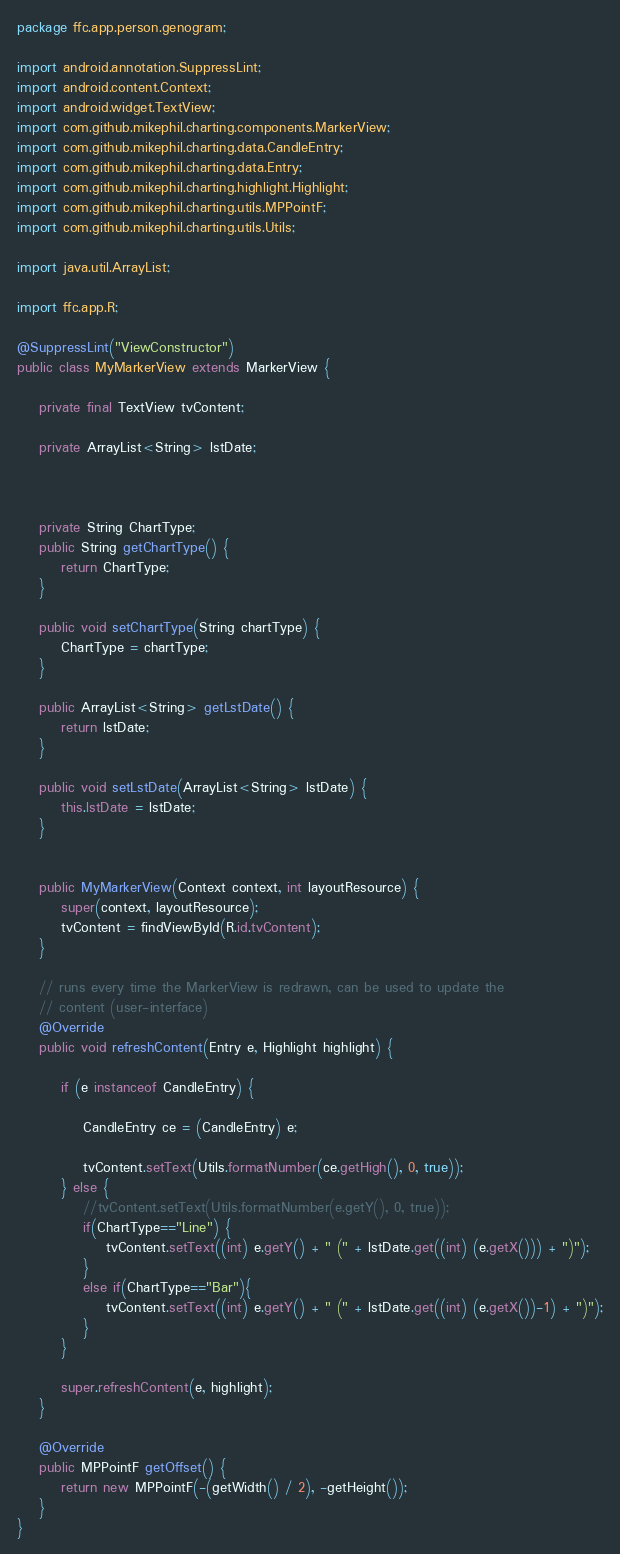<code> <loc_0><loc_0><loc_500><loc_500><_Java_>package ffc.app.person.genogram;

import android.annotation.SuppressLint;
import android.content.Context;
import android.widget.TextView;
import com.github.mikephil.charting.components.MarkerView;
import com.github.mikephil.charting.data.CandleEntry;
import com.github.mikephil.charting.data.Entry;
import com.github.mikephil.charting.highlight.Highlight;
import com.github.mikephil.charting.utils.MPPointF;
import com.github.mikephil.charting.utils.Utils;

import java.util.ArrayList;

import ffc.app.R;

@SuppressLint("ViewConstructor")
public class MyMarkerView extends MarkerView {

    private final TextView tvContent;

    private ArrayList<String> lstDate;



    private String ChartType;
    public String getChartType() {
        return ChartType;
    }

    public void setChartType(String chartType) {
        ChartType = chartType;
    }

    public ArrayList<String> getLstDate() {
        return lstDate;
    }

    public void setLstDate(ArrayList<String> lstDate) {
        this.lstDate = lstDate;
    }


    public MyMarkerView(Context context, int layoutResource) {
        super(context, layoutResource);
        tvContent = findViewById(R.id.tvContent);
    }

    // runs every time the MarkerView is redrawn, can be used to update the
    // content (user-interface)
    @Override
    public void refreshContent(Entry e, Highlight highlight) {

        if (e instanceof CandleEntry) {

            CandleEntry ce = (CandleEntry) e;

            tvContent.setText(Utils.formatNumber(ce.getHigh(), 0, true));
        } else {
            //tvContent.setText(Utils.formatNumber(e.getY(), 0, true));
            if(ChartType=="Line") {
                tvContent.setText((int) e.getY() + " (" + lstDate.get((int) (e.getX())) + ")");
            }
            else if(ChartType=="Bar"){
                tvContent.setText((int) e.getY() + " (" + lstDate.get((int) (e.getX())-1) + ")");
            }
        }

        super.refreshContent(e, highlight);
    }

    @Override
    public MPPointF getOffset() {
        return new MPPointF(-(getWidth() / 2), -getHeight());
    }
}
</code> 